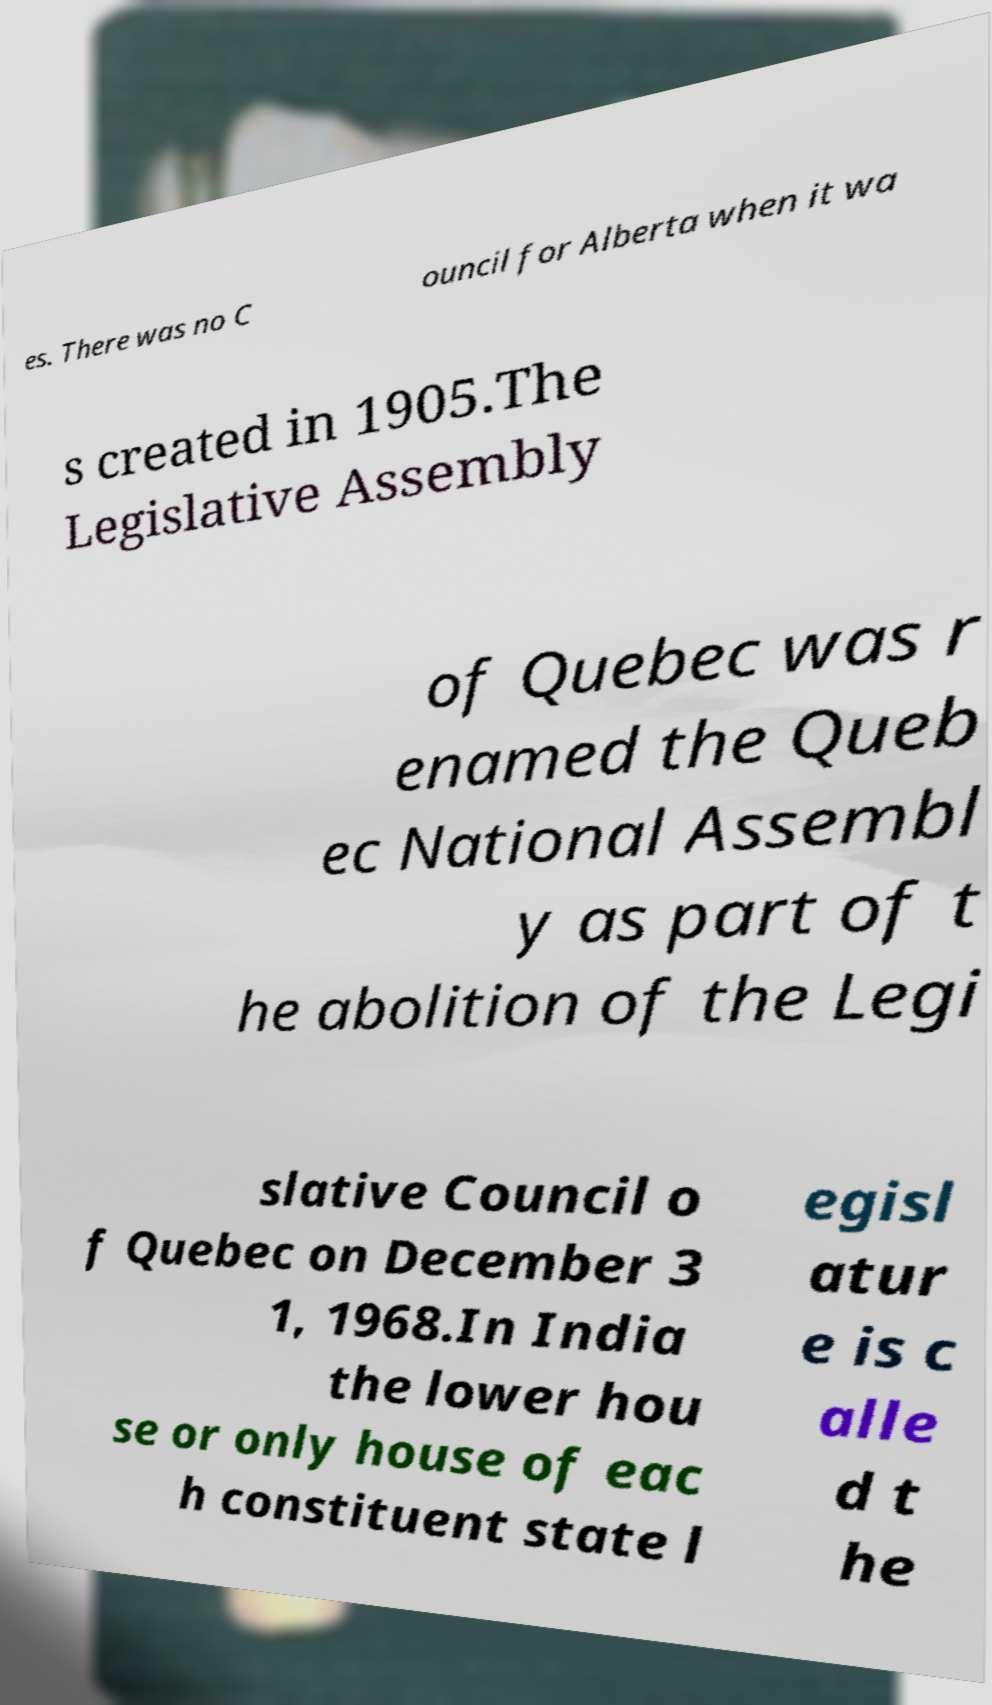Can you read and provide the text displayed in the image?This photo seems to have some interesting text. Can you extract and type it out for me? es. There was no C ouncil for Alberta when it wa s created in 1905.The Legislative Assembly of Quebec was r enamed the Queb ec National Assembl y as part of t he abolition of the Legi slative Council o f Quebec on December 3 1, 1968.In India the lower hou se or only house of eac h constituent state l egisl atur e is c alle d t he 